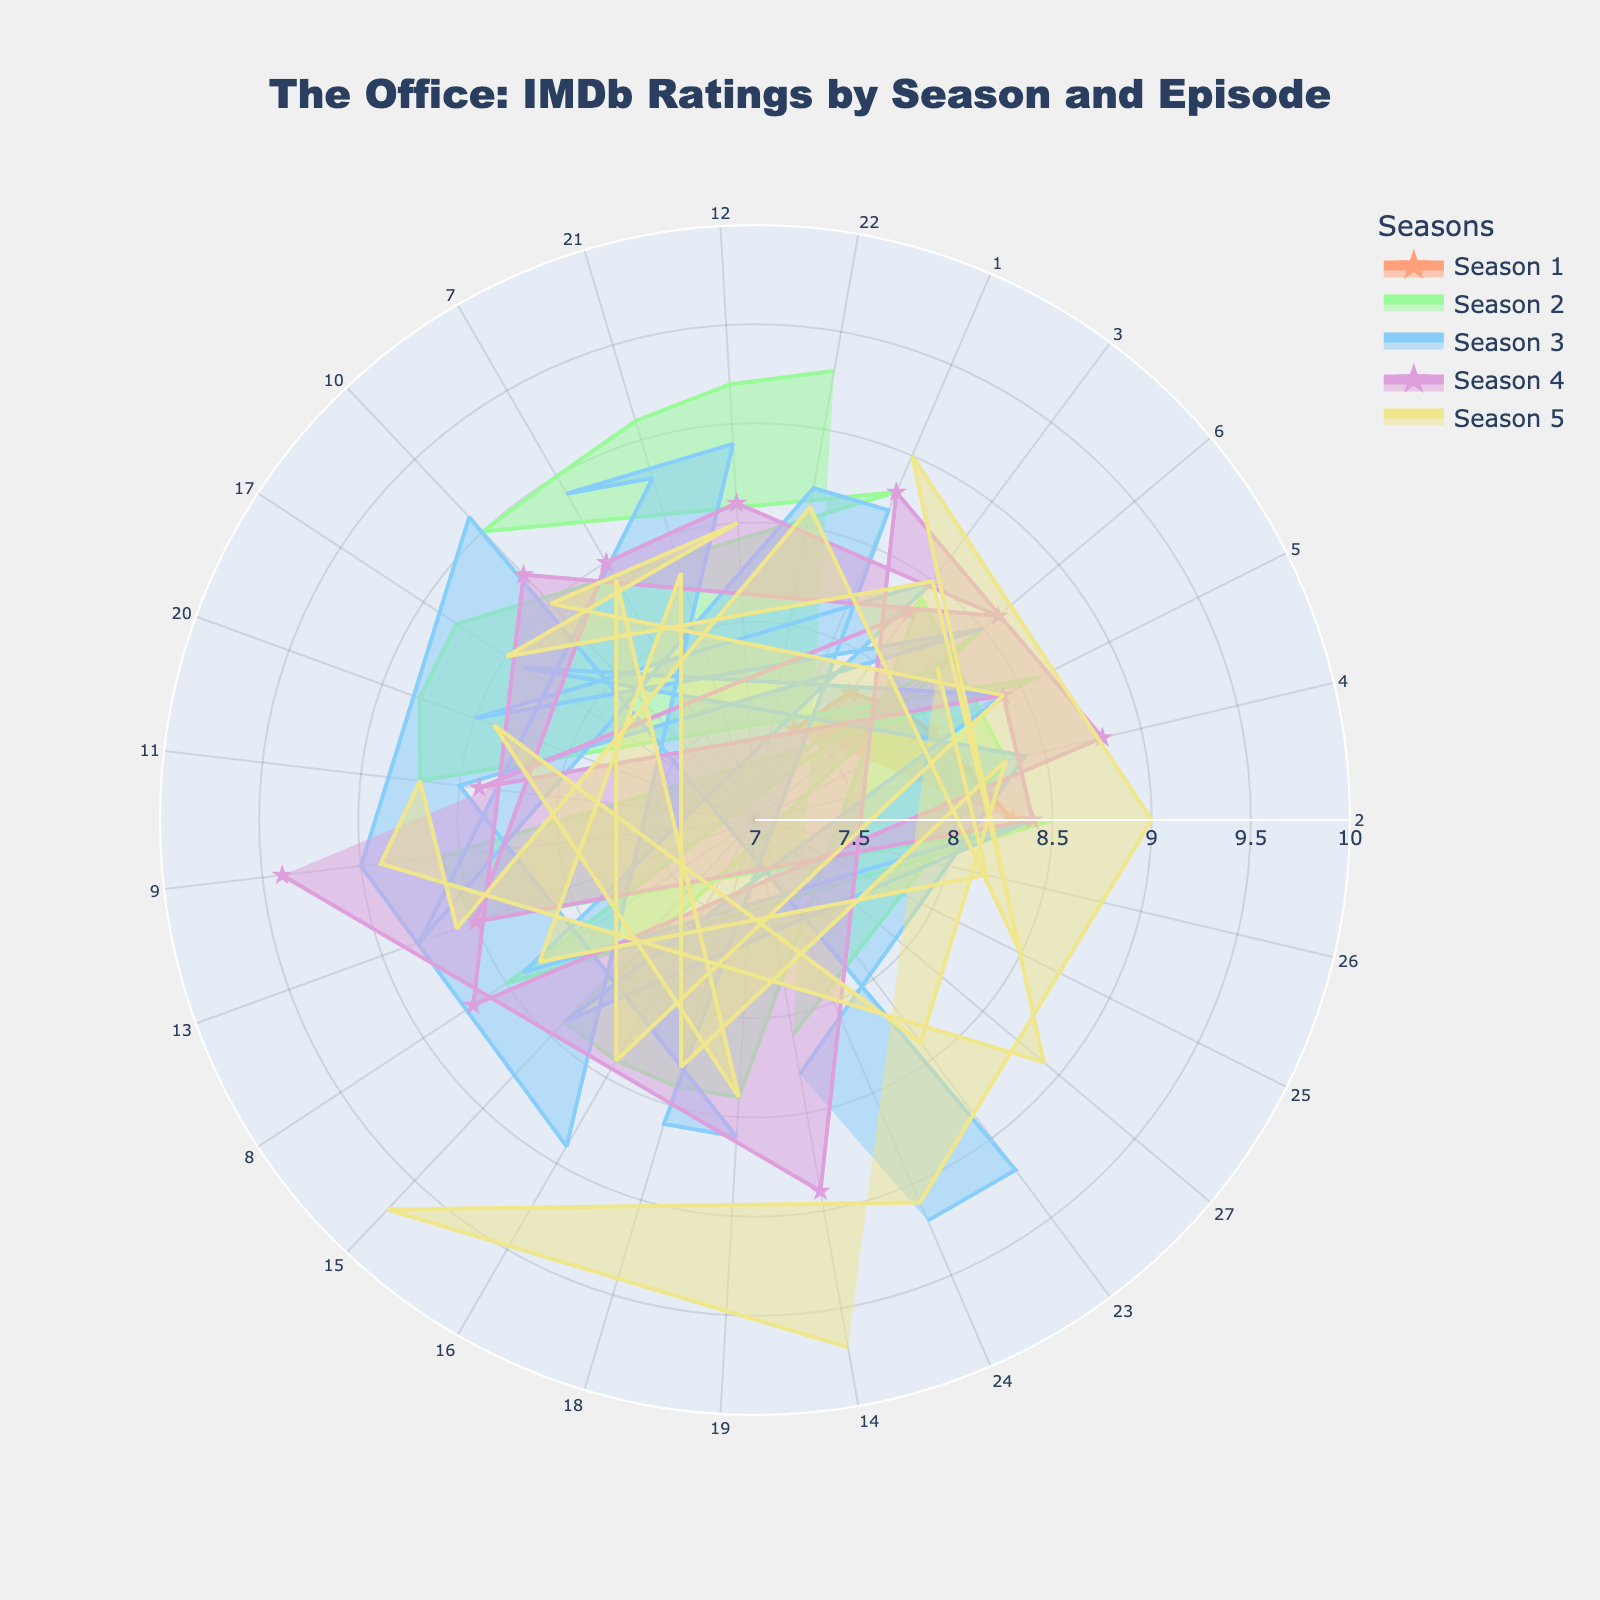What's the highest-rated episode of "The Office"? To find the highest-rated episode, look for the point farthest out on the radial axis, which represents the highest IMDb rating. The highest point is 9.7, which corresponds to "Stress Relief Part 1" and "Stress Relief Part 2" in Season 5.
Answer: "Stress Relief Part 1" and "Stress Relief Part 2" Which season has the most episodes with a rating of 9.0 or higher? Count the number of episodes rated 9.0 or higher in each season. Season 2 has three episodes ("The Client", "Christmas Party", "Casino Night"), Season 3 has five episodes, Season 4 has one episode, and Season 5 has four episodes. Season 3 has the most episodes with a rating of 9.0 or higher.
Answer: Season 3 What is the average IMDb rating of Season 1 episodes? To calculate the average IMDb rating of Season 1, sum the ratings of all Season 1 episodes and divide by the number of episodes. The ratings are 7.5, 8.3, 7.8, 8.1, 8.0, and 7.9. The sum is 47.6, and there are 6 episodes, so the average is 47.6 / 6 = 7.93.
Answer: 7.93 Which episode in Season 4 has the highest IMDb rating? Find the point farthest out on the Season 4 trace (purple color). The highest point corresponds to "Dinner Party" with an IMDb rating of 9.4.
Answer: "Dinner Party" How does the highest rating in Season 2 compare to the highest rating in Season 3? Identify the highest rating in each season. Season 2's highest rating is 9.3 ("Casino Night"), and Season 3's highest rating is 9.2 ("The Job (Part 1)" and "The Job (Part 2)"). Season 2's highest rating is 0.1 higher than Season 3's.
Answer: Season 2's highest rating is 0.1 higher Which season has the highest average IMDb rating? Calculate the average IMDb rating for each season by summing all ratings in each season and dividing by the number of episodes in that season. Compare these averages to determine the highest one.
Answer: Season 4 How many episodes in total are rated above 9.0? Count all episodes with IMDb ratings above 9.0 across all seasons. These episodes are: "The Injury", "Casino Night", "The Convict", "A Benihana Christmas", "The Job (Part 1)", "The Job (Part 2)", "Dinner Party", "Stress Relief Part 1", "Stress Relief Part 2", and "Broke". The total is 10.
Answer: 10 Which season has the episode with the lowest IMDb rating, and what is that rating? Look for the point closest to the center of the chart, indicating the lowest IMDb rating. The lowest rating is 7.5, which belongs to the "Pilot" episode in Season 1.
Answer: Season 1, 7.5 How does the distribution of ratings in Season 5 compare to that in Season 1? Observe the spread of points for Season 5 (yellow color) and Season 1 (salmon color). Season 5's ratings range from 8.2 to 9.7, showing a wider spread with higher values, whereas Season 1's ratings range from 7.5 to 8.3, indicating a narrower, lower range.
Answer: Season 5 has a wider and higher distribution of ratings 